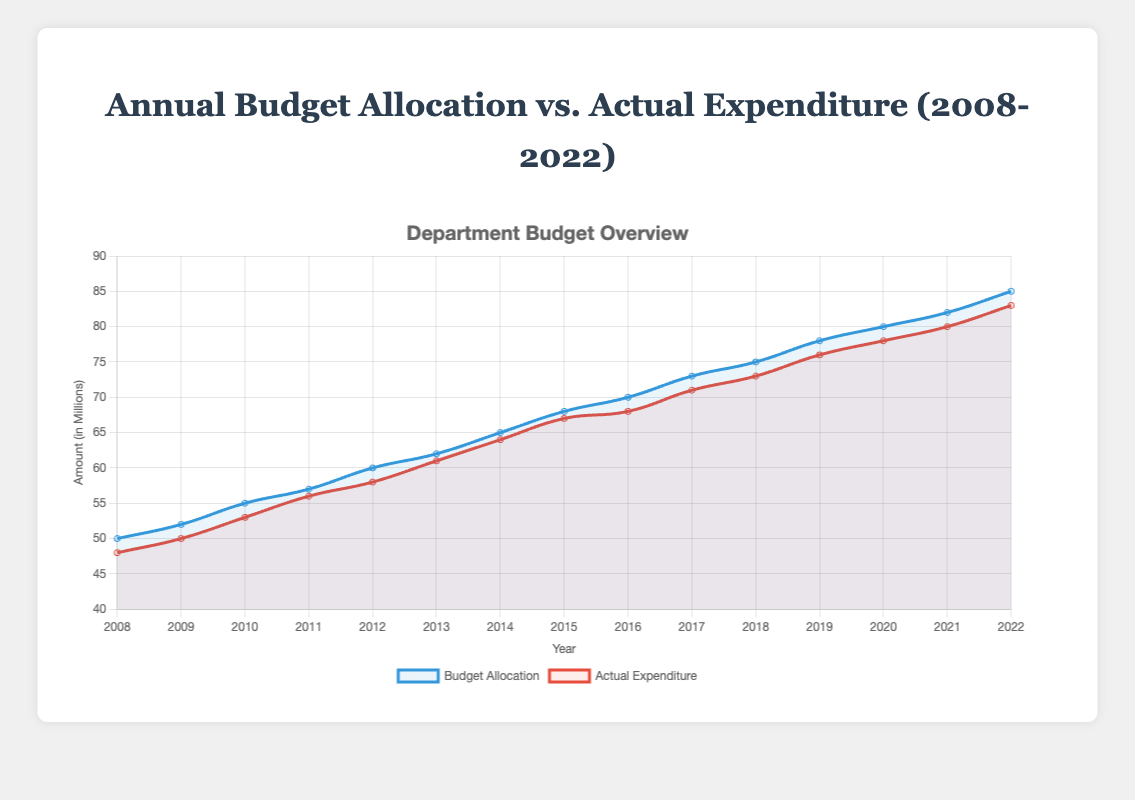What is the highest value of actual expenditure within the 15-year span? The highest value of actual expenditure occurs in the last year, 2022, where the actual expenditure is $83 million.
Answer: $83 million In which year did the budget allocation first reach $70 million? By observing the 'Budget Allocation' line, the first time it hits $70 million is in the year 2016.
Answer: 2016 During which year was the gap between budget allocation and actual expenditure the largest? To find the year with the largest gap, we need to calculate the difference between the budget and actual expenditure for each year, and compare them. The largest difference occurs in 2008 with a gap of $2 million (50 - 48).
Answer: 2008 How much did the budget allocation increase from 2008 to 2022? Calculate the difference between the budget in 2022 and 2008. In 2022, the budget is $85 million, and in 2008, it was $50 million. Hence, the increase is 85 - 50 = $35 million.
Answer: $35 million Which year had the smallest difference between the budget allocation and the actual expenditure? To determine this, we need to calculate the difference for each year and compare them. The smallest difference occurs in 2014 with only a $1 million difference.
Answer: 2014 Is there a trend where actual expenditure consistently matches the budget allocation over the years? By visually examining the plot, we can see that actual expenditure is consistently slightly less than the budget allocation every year, indicating a trend where actual expenditure is close but not equal to the allocated budget.
Answer: Yes, consistently less From 2008 to 2022, identify a year when the actual expenditure surpassed the budget allocation. By checking the plot, such a year does not exist for this period, as actual expenditure is always slightly less than the budget allocation.
Answer: None What is the average actual expenditure over these 15 years? Sum up all the actual expenditure values from 2008 to 2022 and divide by 15. Total actual expenditure = 48+50+53+56+58+61+64+67+68+71+73+76+78+80+83 = $906 million. Thus, the average is 906/15 ≈ $60.4 million.
Answer: $60.4 million By how much did the budget allocation increase from 2019 to 2020? In 2019, the budget allocation was $78 million, and in 2020, it was $80 million. The increase is 80 - 78 = $2 million.
Answer: $2 million Was actual expenditure ever equal to the budget allocation in any given year? By checking the actual expenditure and budget allocation values for each year, there is no instance where actual expenditure exactly equals the budget allocation.
Answer: No 